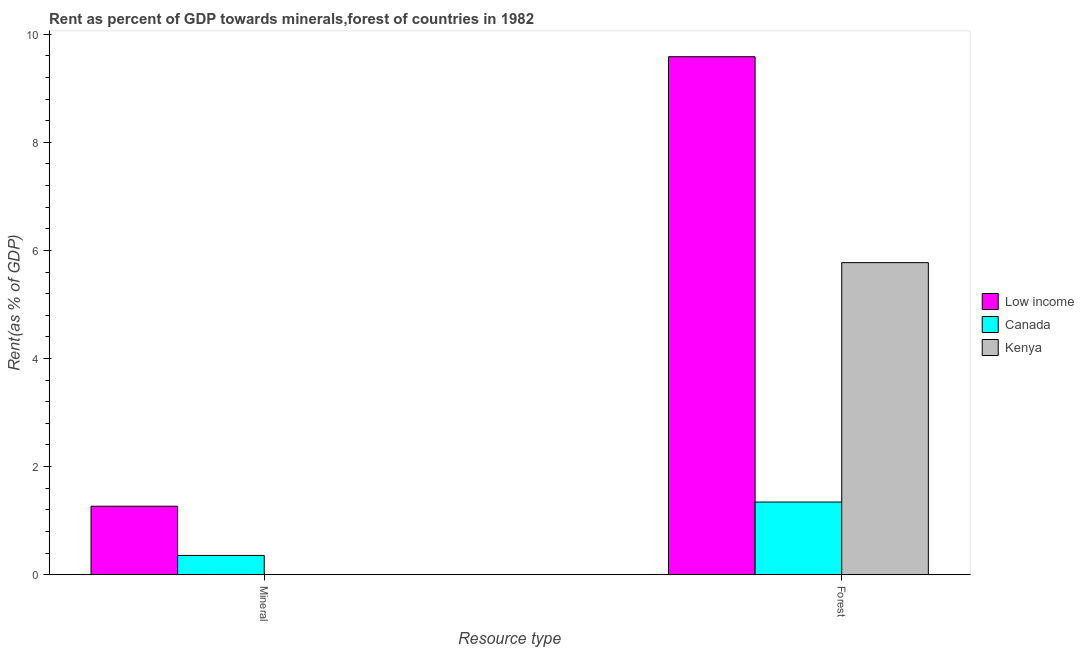How many different coloured bars are there?
Provide a succinct answer. 3. How many groups of bars are there?
Your answer should be very brief. 2. Are the number of bars on each tick of the X-axis equal?
Your answer should be very brief. Yes. How many bars are there on the 2nd tick from the left?
Provide a short and direct response. 3. How many bars are there on the 2nd tick from the right?
Provide a succinct answer. 3. What is the label of the 2nd group of bars from the left?
Your answer should be compact. Forest. What is the forest rent in Low income?
Keep it short and to the point. 9.59. Across all countries, what is the maximum mineral rent?
Provide a succinct answer. 1.27. Across all countries, what is the minimum mineral rent?
Provide a short and direct response. 6.72101396452568e-5. What is the total mineral rent in the graph?
Give a very brief answer. 1.62. What is the difference between the mineral rent in Kenya and that in Canada?
Offer a very short reply. -0.36. What is the difference between the forest rent in Kenya and the mineral rent in Low income?
Provide a short and direct response. 4.51. What is the average mineral rent per country?
Ensure brevity in your answer.  0.54. What is the difference between the forest rent and mineral rent in Low income?
Offer a very short reply. 8.32. What is the ratio of the forest rent in Canada to that in Low income?
Provide a succinct answer. 0.14. What does the 1st bar from the left in Mineral represents?
Give a very brief answer. Low income. What does the 3rd bar from the right in Forest represents?
Provide a succinct answer. Low income. How many countries are there in the graph?
Provide a short and direct response. 3. What is the difference between two consecutive major ticks on the Y-axis?
Give a very brief answer. 2. Are the values on the major ticks of Y-axis written in scientific E-notation?
Give a very brief answer. No. Does the graph contain any zero values?
Offer a terse response. No. Where does the legend appear in the graph?
Your response must be concise. Center right. What is the title of the graph?
Give a very brief answer. Rent as percent of GDP towards minerals,forest of countries in 1982. What is the label or title of the X-axis?
Your answer should be very brief. Resource type. What is the label or title of the Y-axis?
Your response must be concise. Rent(as % of GDP). What is the Rent(as % of GDP) in Low income in Mineral?
Ensure brevity in your answer.  1.27. What is the Rent(as % of GDP) in Canada in Mineral?
Offer a very short reply. 0.36. What is the Rent(as % of GDP) of Kenya in Mineral?
Your answer should be very brief. 6.72101396452568e-5. What is the Rent(as % of GDP) of Low income in Forest?
Provide a short and direct response. 9.59. What is the Rent(as % of GDP) in Canada in Forest?
Offer a terse response. 1.34. What is the Rent(as % of GDP) of Kenya in Forest?
Offer a very short reply. 5.77. Across all Resource type, what is the maximum Rent(as % of GDP) of Low income?
Your answer should be compact. 9.59. Across all Resource type, what is the maximum Rent(as % of GDP) in Canada?
Offer a very short reply. 1.34. Across all Resource type, what is the maximum Rent(as % of GDP) in Kenya?
Offer a terse response. 5.77. Across all Resource type, what is the minimum Rent(as % of GDP) in Low income?
Keep it short and to the point. 1.27. Across all Resource type, what is the minimum Rent(as % of GDP) of Canada?
Offer a terse response. 0.36. Across all Resource type, what is the minimum Rent(as % of GDP) of Kenya?
Offer a very short reply. 6.72101396452568e-5. What is the total Rent(as % of GDP) in Low income in the graph?
Offer a terse response. 10.85. What is the total Rent(as % of GDP) of Canada in the graph?
Provide a succinct answer. 1.7. What is the total Rent(as % of GDP) in Kenya in the graph?
Offer a terse response. 5.77. What is the difference between the Rent(as % of GDP) of Low income in Mineral and that in Forest?
Keep it short and to the point. -8.32. What is the difference between the Rent(as % of GDP) in Canada in Mineral and that in Forest?
Keep it short and to the point. -0.99. What is the difference between the Rent(as % of GDP) in Kenya in Mineral and that in Forest?
Make the answer very short. -5.77. What is the difference between the Rent(as % of GDP) of Low income in Mineral and the Rent(as % of GDP) of Canada in Forest?
Offer a terse response. -0.08. What is the difference between the Rent(as % of GDP) of Low income in Mineral and the Rent(as % of GDP) of Kenya in Forest?
Provide a short and direct response. -4.51. What is the difference between the Rent(as % of GDP) of Canada in Mineral and the Rent(as % of GDP) of Kenya in Forest?
Your response must be concise. -5.42. What is the average Rent(as % of GDP) of Low income per Resource type?
Your answer should be compact. 5.43. What is the average Rent(as % of GDP) of Canada per Resource type?
Offer a terse response. 0.85. What is the average Rent(as % of GDP) of Kenya per Resource type?
Provide a succinct answer. 2.89. What is the difference between the Rent(as % of GDP) in Low income and Rent(as % of GDP) in Canada in Mineral?
Keep it short and to the point. 0.91. What is the difference between the Rent(as % of GDP) in Low income and Rent(as % of GDP) in Kenya in Mineral?
Offer a very short reply. 1.27. What is the difference between the Rent(as % of GDP) in Canada and Rent(as % of GDP) in Kenya in Mineral?
Your answer should be compact. 0.36. What is the difference between the Rent(as % of GDP) in Low income and Rent(as % of GDP) in Canada in Forest?
Keep it short and to the point. 8.24. What is the difference between the Rent(as % of GDP) in Low income and Rent(as % of GDP) in Kenya in Forest?
Ensure brevity in your answer.  3.81. What is the difference between the Rent(as % of GDP) of Canada and Rent(as % of GDP) of Kenya in Forest?
Offer a very short reply. -4.43. What is the ratio of the Rent(as % of GDP) in Low income in Mineral to that in Forest?
Offer a terse response. 0.13. What is the ratio of the Rent(as % of GDP) in Canada in Mineral to that in Forest?
Your answer should be very brief. 0.27. What is the difference between the highest and the second highest Rent(as % of GDP) in Low income?
Ensure brevity in your answer.  8.32. What is the difference between the highest and the second highest Rent(as % of GDP) of Canada?
Your response must be concise. 0.99. What is the difference between the highest and the second highest Rent(as % of GDP) in Kenya?
Give a very brief answer. 5.77. What is the difference between the highest and the lowest Rent(as % of GDP) in Low income?
Keep it short and to the point. 8.32. What is the difference between the highest and the lowest Rent(as % of GDP) of Kenya?
Give a very brief answer. 5.77. 